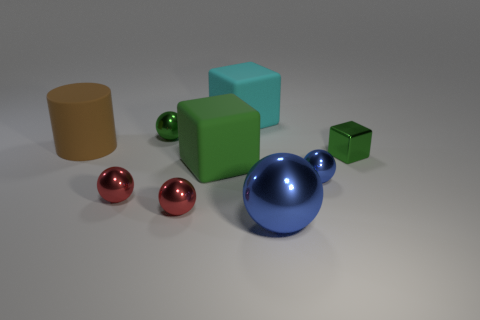Does the large cyan thing have the same shape as the big green thing?
Provide a short and direct response. Yes. The other blue metallic object that is the same shape as the large blue thing is what size?
Provide a succinct answer. Small. How many big green cubes are the same material as the cyan cube?
Provide a succinct answer. 1. How many things are either blue cylinders or large cyan things?
Make the answer very short. 1. There is a block that is on the right side of the big shiny thing; are there any matte things that are in front of it?
Offer a very short reply. Yes. Are there more spheres that are on the right side of the green matte thing than large green matte blocks to the left of the large blue shiny sphere?
Provide a short and direct response. Yes. There is a small thing that is the same color as the tiny block; what is its material?
Ensure brevity in your answer.  Metal. How many small balls have the same color as the large shiny thing?
Offer a terse response. 1. Is the color of the small sphere that is behind the brown object the same as the matte object that is behind the big cylinder?
Ensure brevity in your answer.  No. There is a large cyan matte thing; are there any green rubber objects right of it?
Make the answer very short. No. 